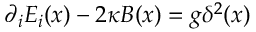<formula> <loc_0><loc_0><loc_500><loc_500>\partial _ { i } E _ { i } ( x ) - 2 \kappa B ( x ) = g \delta ^ { 2 } ( x )</formula> 